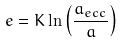<formula> <loc_0><loc_0><loc_500><loc_500>e = K \ln \left ( \frac { a _ { e c c } } { a } \right )</formula> 